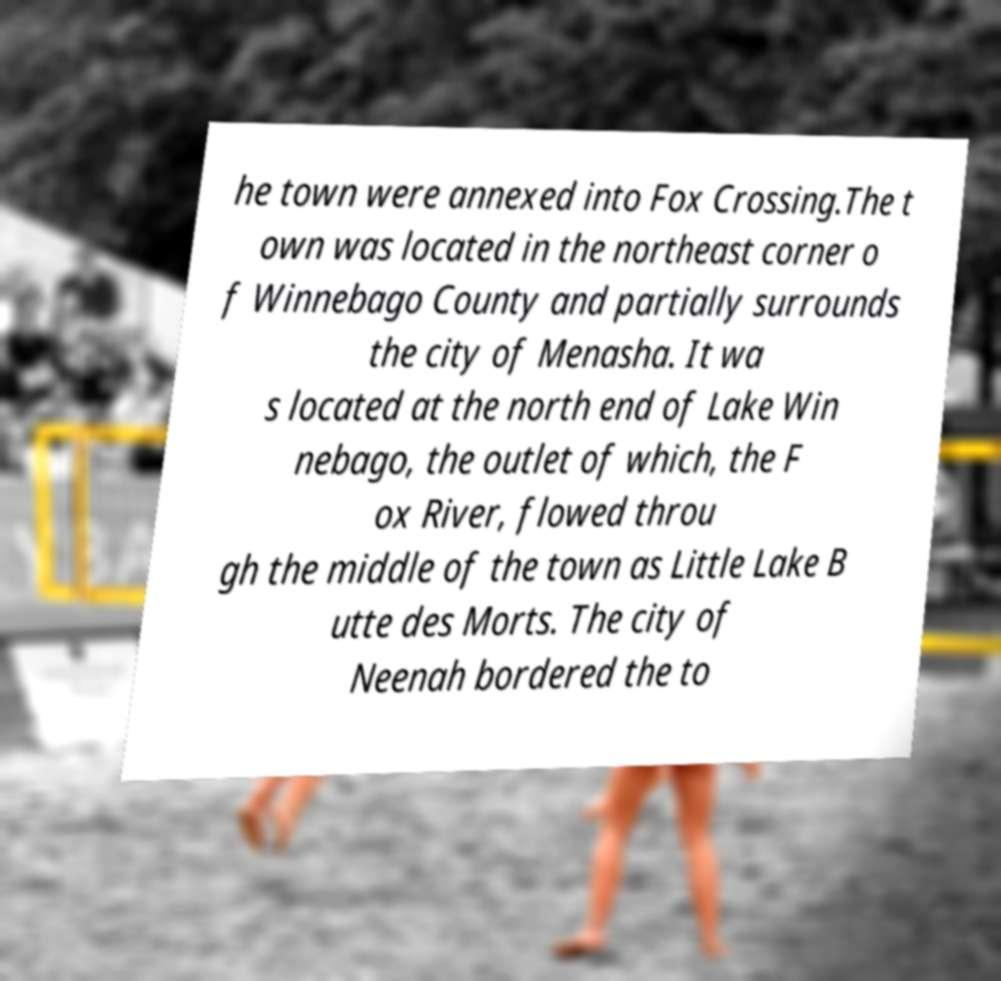Could you extract and type out the text from this image? he town were annexed into Fox Crossing.The t own was located in the northeast corner o f Winnebago County and partially surrounds the city of Menasha. It wa s located at the north end of Lake Win nebago, the outlet of which, the F ox River, flowed throu gh the middle of the town as Little Lake B utte des Morts. The city of Neenah bordered the to 